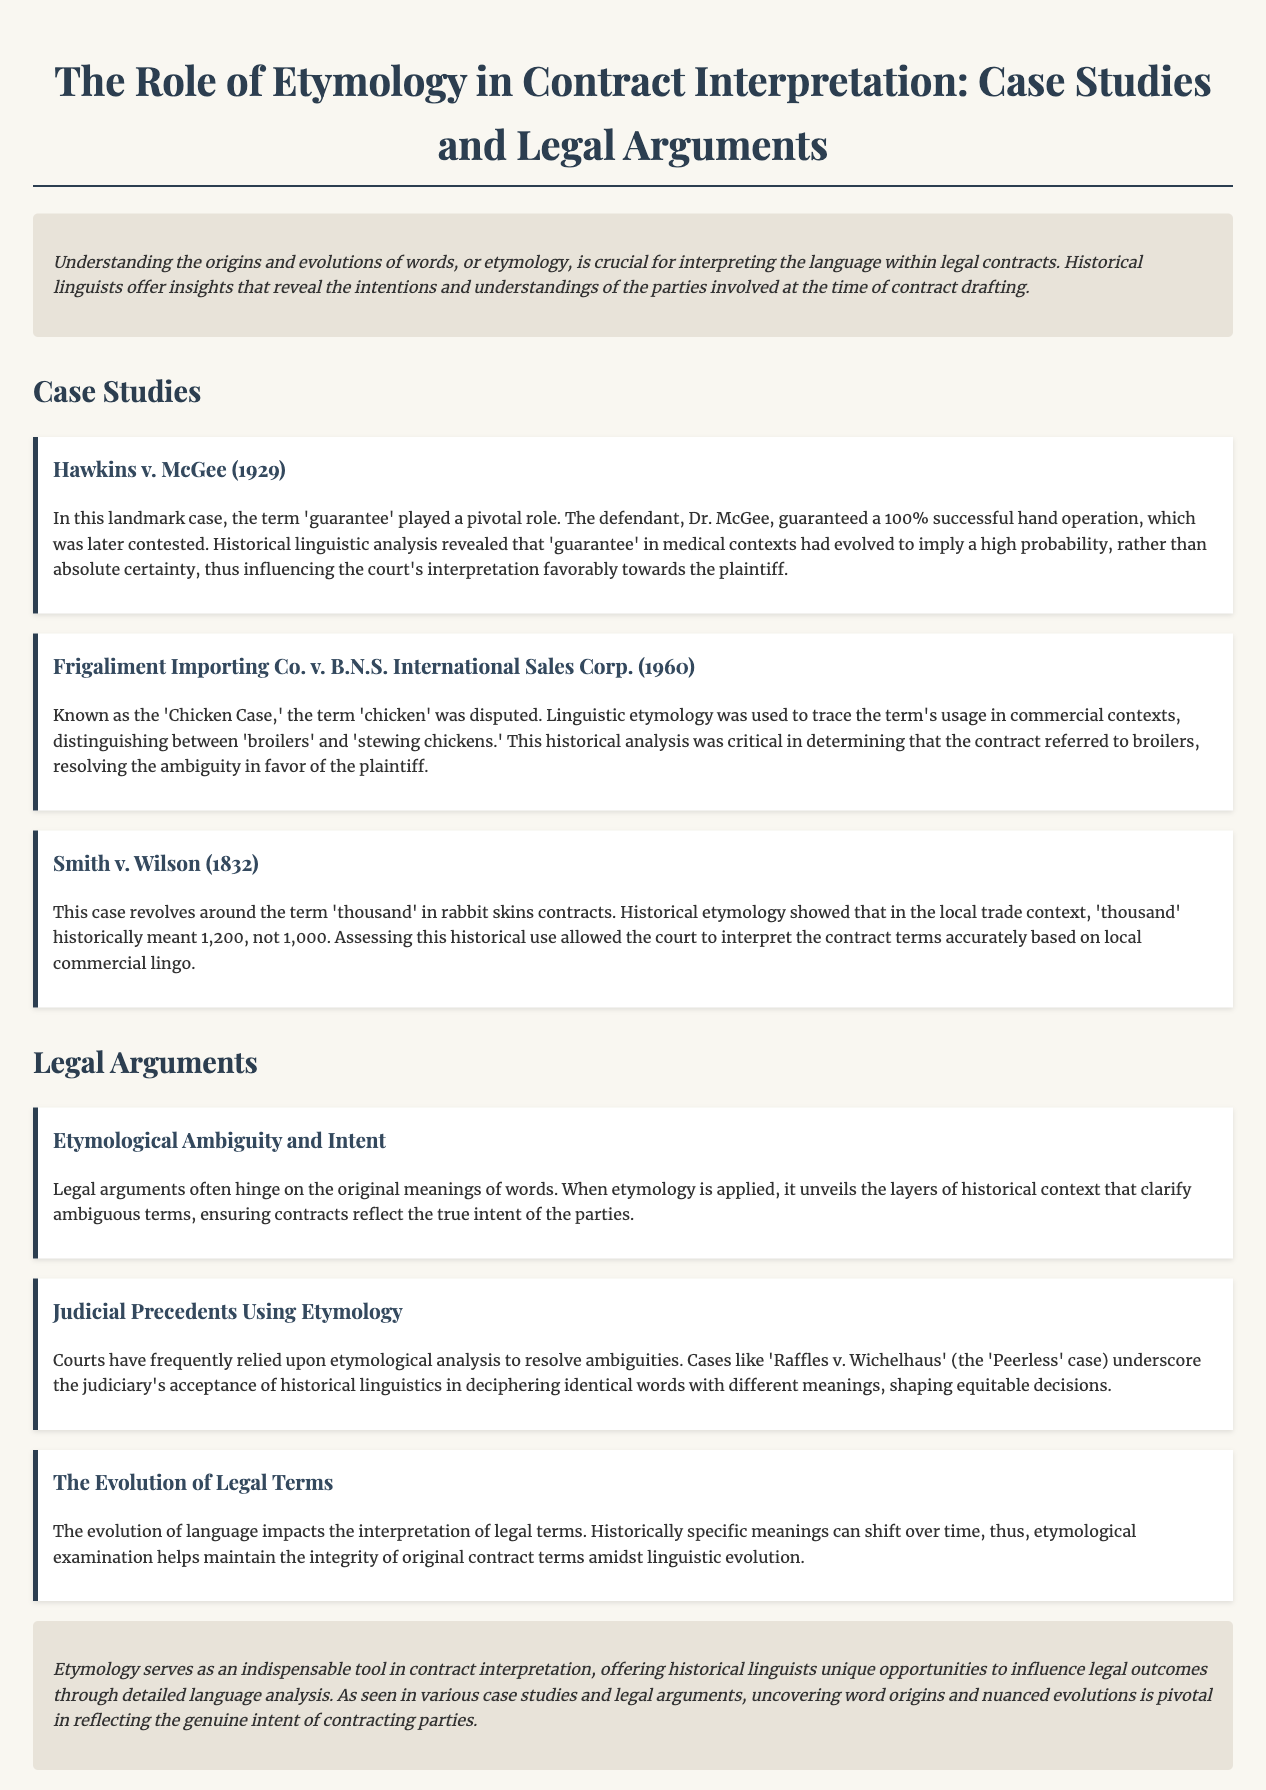What is the title of the document? The title of the document is stated in the `<title>` tag of the HTML, which presents the main theme of the legal brief.
Answer: The Role of Etymology in Contract Interpretation: Case Studies and Legal Arguments In which case was the term 'guarantee' pivotal? The case where the term 'guarantee' played a pivotal role is mentioned as a key study in the document.
Answer: Hawkins v. McGee What year was the 'Chicken Case' decided? The year the 'Chicken Case' was decided is found in the header of the case study section within the text.
Answer: 1960 What does the term 'thousand' refer to in Smith v. Wilson? The explanation of the term 'thousand' in the context of rabbit skins contracts indicates its specific meaning based on historical usage.
Answer: 1,200 Which case is known as the 'Peerless' case? This term is used in the legal argument section to highlight an important judicial precedent related to etymology.
Answer: Raffles v. Wichelhaus What role does etymology serve in contract interpretation? The document describes the function of etymology within the context of legal contracts, especially in revealing intentions and clarifying meanings.
Answer: Indispensable tool What is a key outcome of applying historical linguistics in court cases? The language applied in legal arguments often uncovers layers of historical context, offering clarity on ambiguous terms in contracts.
Answer: True intent What are the two primary sections of the document? The main sections are clearly separated by headings in the text, indicating the structure of the document.
Answer: Case Studies and Legal Arguments What was a focus of the case Smith v. Wilson? The focus of the case discussed in the document emphasizes how etymology influences contract terms based on local trade context.
Answer: Rabbit skins contracts 